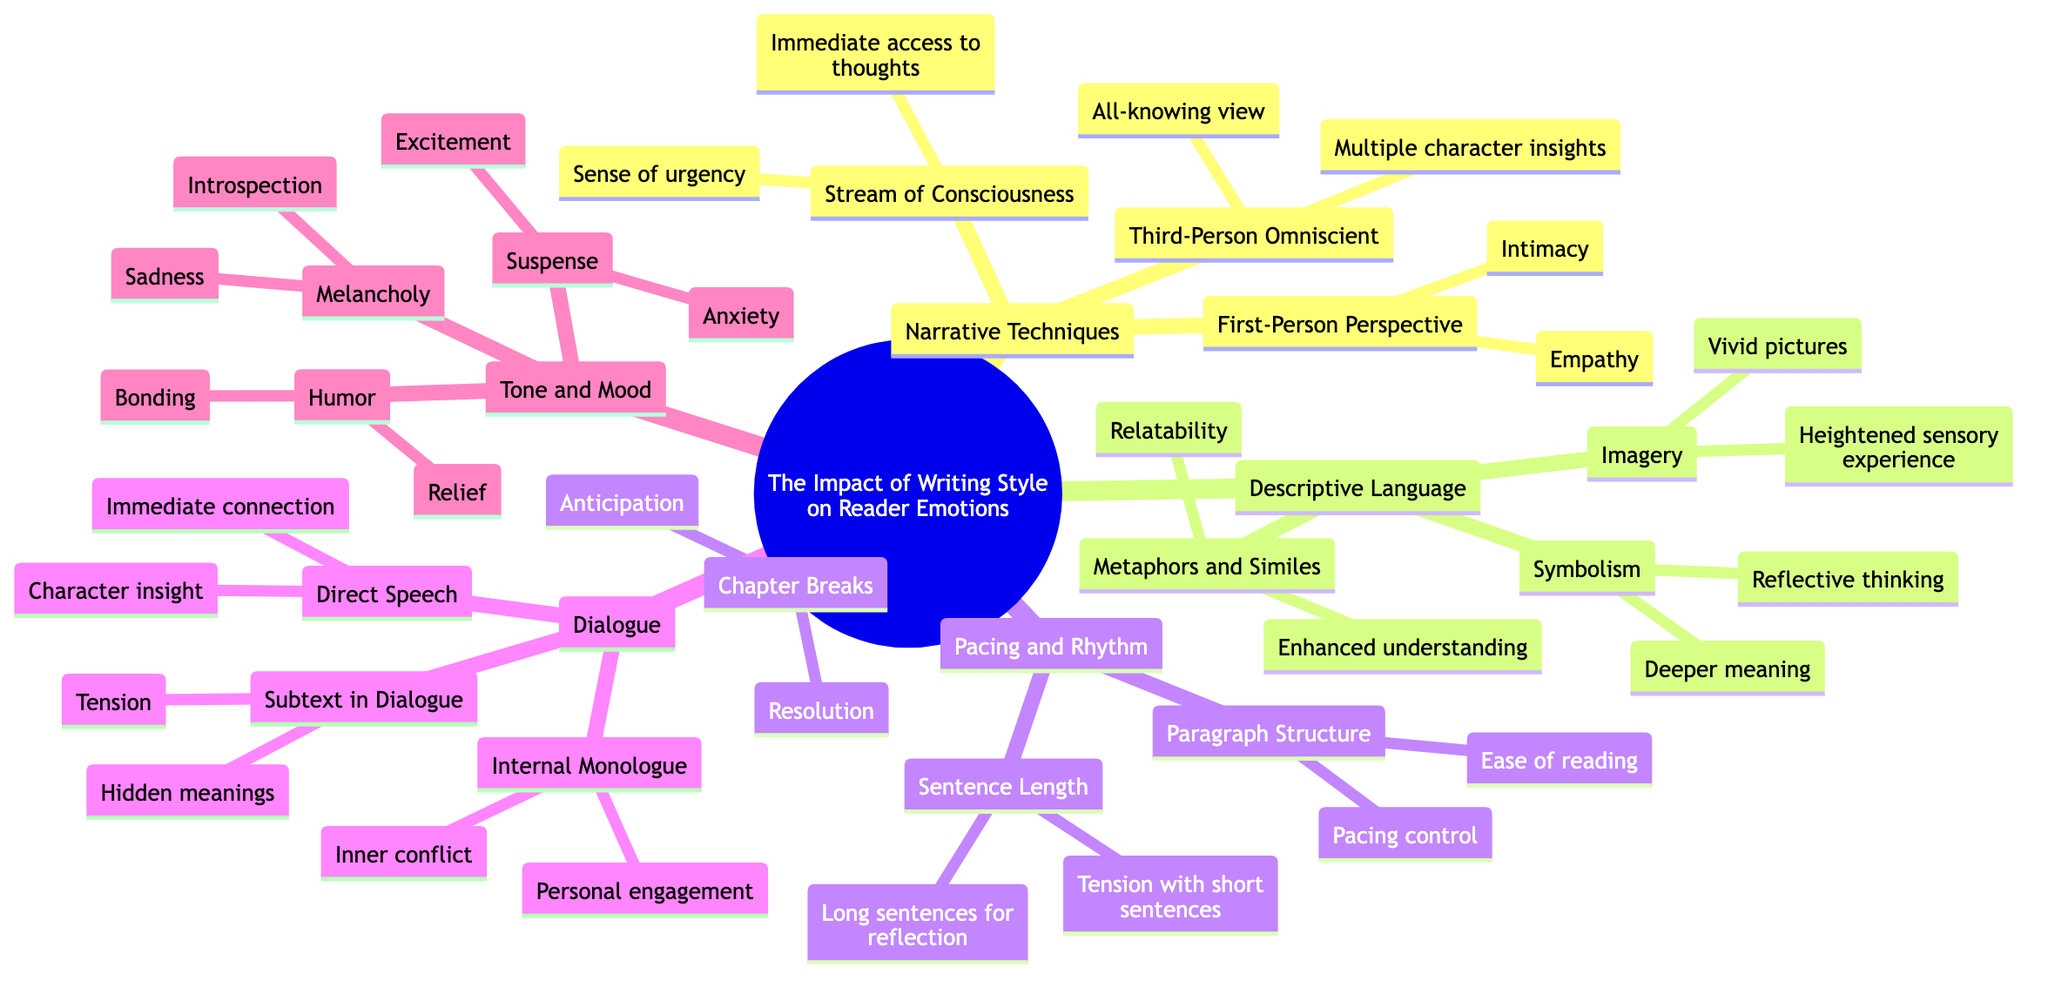What are the emotional effects of the First-Person Perspective? The diagram indicates "Intimacy" and "Empathy" as the emotional effects listed under First-Person Perspective.
Answer: Intimacy, Empathy How many subtopics are in the mind map? The central topic has five main subtopics listed: Narrative Techniques, Descriptive Language, Pacing and Rhythm, Dialogue, and Tone and Mood. Counting these subtopics gives a total of five.
Answer: 5 What emotional effect is associated with Chapter Breaks? The diagram shows "Anticipation" and "Resolution" as the emotional effects connected to Chapter Breaks.
Answer: Anticipation, Resolution Which narrative technique provides access to immediate thoughts? The "Stream of Consciousness" technique is listed as providing "Immediate access to thoughts," according to the details in the diagram.
Answer: Stream of Consciousness What emotional effects are listed under Symbolism? The effects tied to Symbolism in the diagram are "Deeper meaning" and "Reflective thinking," which illustrates the emotional impact of using symbolic elements in writing.
Answer: Deeper meaning, Reflective thinking Which element of Dialogue offers hidden meanings? The diagram indicates that "Subtext in Dialogue" is the element that conveys "Hidden meanings" as one of its emotional effects.
Answer: Subtext in Dialogue What is the emotional effect of Humor? According to the diagram, Humor leads to "Relief" and "Bonding," indicating how humor can enhance emotional responses in narratives.
Answer: Relief, Bonding How does pacing control relate to Paragraph Structure? The diagram states that in Paragraph Structure, the emotional effect is "Pacing control," which suggests that the way paragraphs are structured directly influences the pacing of the narrative.
Answer: Pacing control What emotional effect is associated with short sentences? The emotional effect tied to short sentences is "Tension," as indicated in the Pacing and Rhythm section of the diagram.
Answer: Tension 